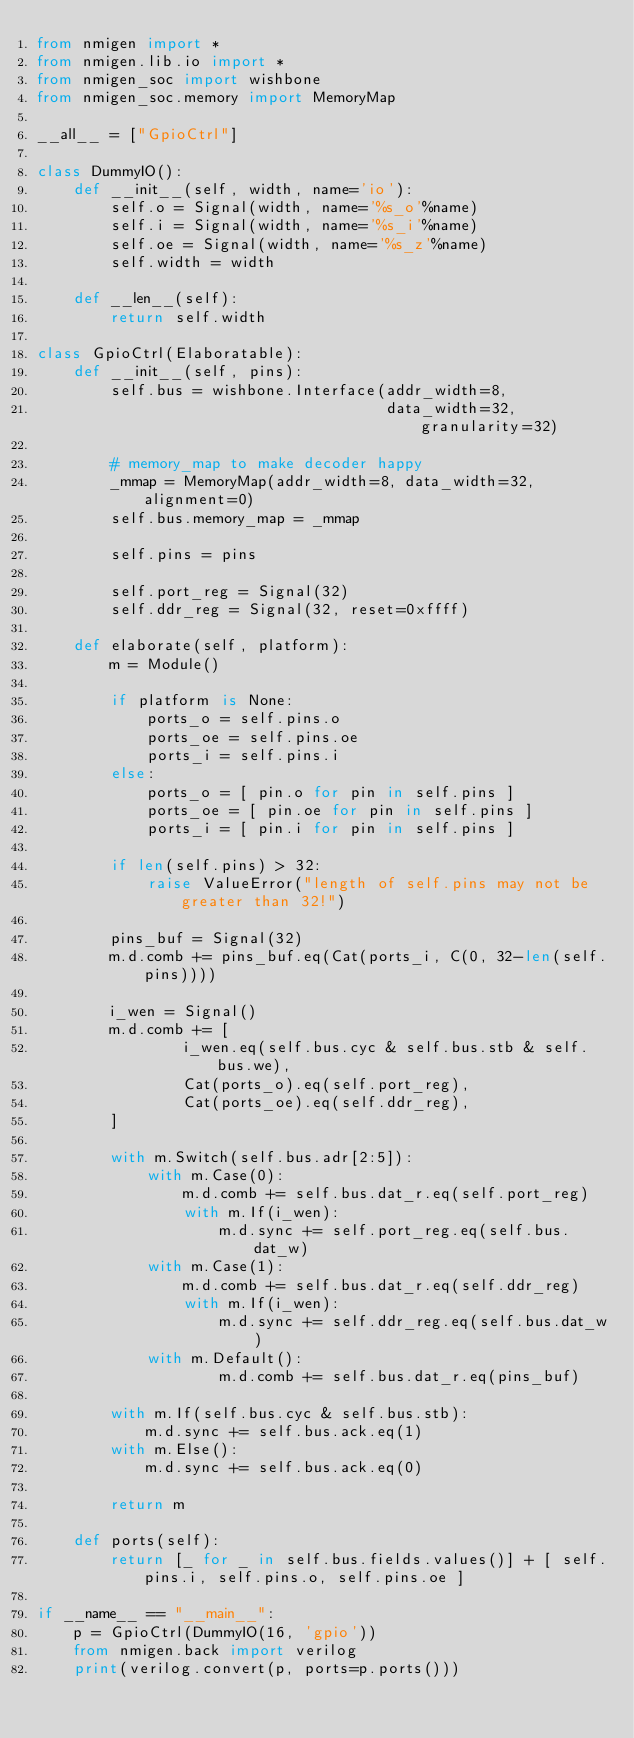<code> <loc_0><loc_0><loc_500><loc_500><_Python_>from nmigen import *
from nmigen.lib.io import *
from nmigen_soc import wishbone
from nmigen_soc.memory import MemoryMap

__all__ = ["GpioCtrl"]

class DummyIO():
    def __init__(self, width, name='io'):
        self.o = Signal(width, name='%s_o'%name)
        self.i = Signal(width, name='%s_i'%name)
        self.oe = Signal(width, name='%s_z'%name)
        self.width = width

    def __len__(self):
        return self.width

class GpioCtrl(Elaboratable):
    def __init__(self, pins):
        self.bus = wishbone.Interface(addr_width=8,
                                      data_width=32, granularity=32)

        # memory_map to make decoder happy
        _mmap = MemoryMap(addr_width=8, data_width=32, alignment=0)
        self.bus.memory_map = _mmap

        self.pins = pins

        self.port_reg = Signal(32)
        self.ddr_reg = Signal(32, reset=0xffff)

    def elaborate(self, platform):
        m = Module()

        if platform is None:
            ports_o = self.pins.o
            ports_oe = self.pins.oe
            ports_i = self.pins.i
        else:
            ports_o = [ pin.o for pin in self.pins ]
            ports_oe = [ pin.oe for pin in self.pins ]
            ports_i = [ pin.i for pin in self.pins ]

        if len(self.pins) > 32:
            raise ValueError("length of self.pins may not be greater than 32!")

        pins_buf = Signal(32)
        m.d.comb += pins_buf.eq(Cat(ports_i, C(0, 32-len(self.pins))))

        i_wen = Signal()
        m.d.comb += [
                i_wen.eq(self.bus.cyc & self.bus.stb & self.bus.we),
                Cat(ports_o).eq(self.port_reg),
                Cat(ports_oe).eq(self.ddr_reg),
        ]

        with m.Switch(self.bus.adr[2:5]):
            with m.Case(0): 
                m.d.comb += self.bus.dat_r.eq(self.port_reg)
                with m.If(i_wen):
                    m.d.sync += self.port_reg.eq(self.bus.dat_w)
            with m.Case(1):
                m.d.comb += self.bus.dat_r.eq(self.ddr_reg)
                with m.If(i_wen):
                    m.d.sync += self.ddr_reg.eq(self.bus.dat_w)
            with m.Default():
                    m.d.comb += self.bus.dat_r.eq(pins_buf)

        with m.If(self.bus.cyc & self.bus.stb):
            m.d.sync += self.bus.ack.eq(1)
        with m.Else():
            m.d.sync += self.bus.ack.eq(0)

        return m

    def ports(self):
        return [_ for _ in self.bus.fields.values()] + [ self.pins.i, self.pins.o, self.pins.oe ]

if __name__ == "__main__":
    p = GpioCtrl(DummyIO(16, 'gpio'))
    from nmigen.back import verilog
    print(verilog.convert(p, ports=p.ports()))
</code> 